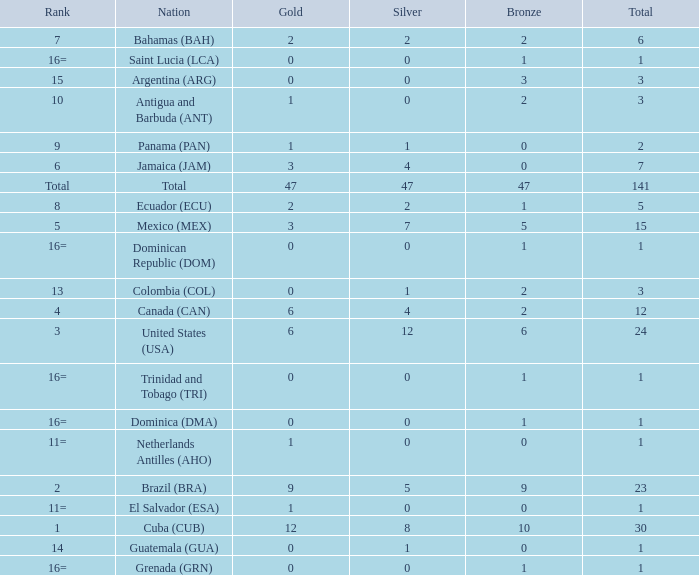How many bronzes have a Nation of jamaica (jam), and a Total smaller than 7? 0.0. 